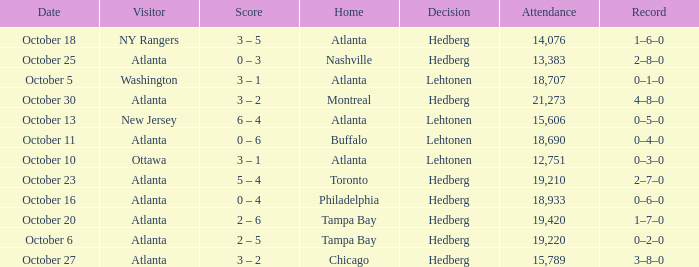What was the record on the game that was played on october 27? 3–8–0. 